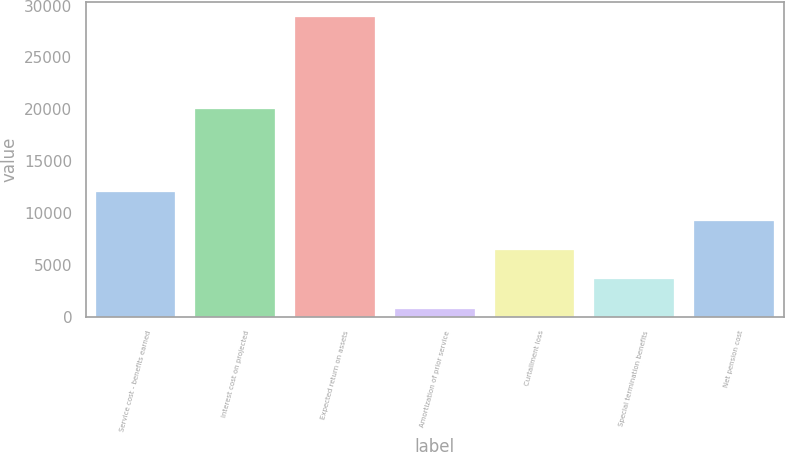<chart> <loc_0><loc_0><loc_500><loc_500><bar_chart><fcel>Service cost - benefits earned<fcel>Interest cost on projected<fcel>Expected return on assets<fcel>Amortization of prior service<fcel>Curtailment loss<fcel>Special termination benefits<fcel>Net pension cost<nl><fcel>12041<fcel>20028<fcel>28919<fcel>789<fcel>6415<fcel>3602<fcel>9228<nl></chart> 